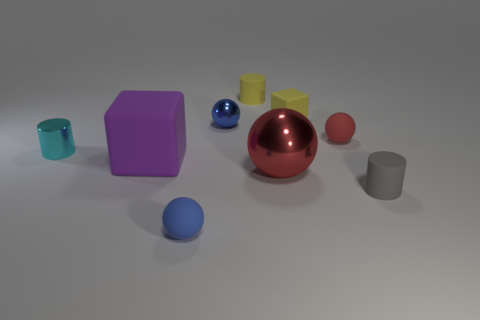Add 1 large red spheres. How many objects exist? 10 Subtract all balls. How many objects are left? 5 Subtract 2 red balls. How many objects are left? 7 Subtract all tiny red things. Subtract all large red metallic objects. How many objects are left? 7 Add 9 red rubber things. How many red rubber things are left? 10 Add 3 metallic spheres. How many metallic spheres exist? 5 